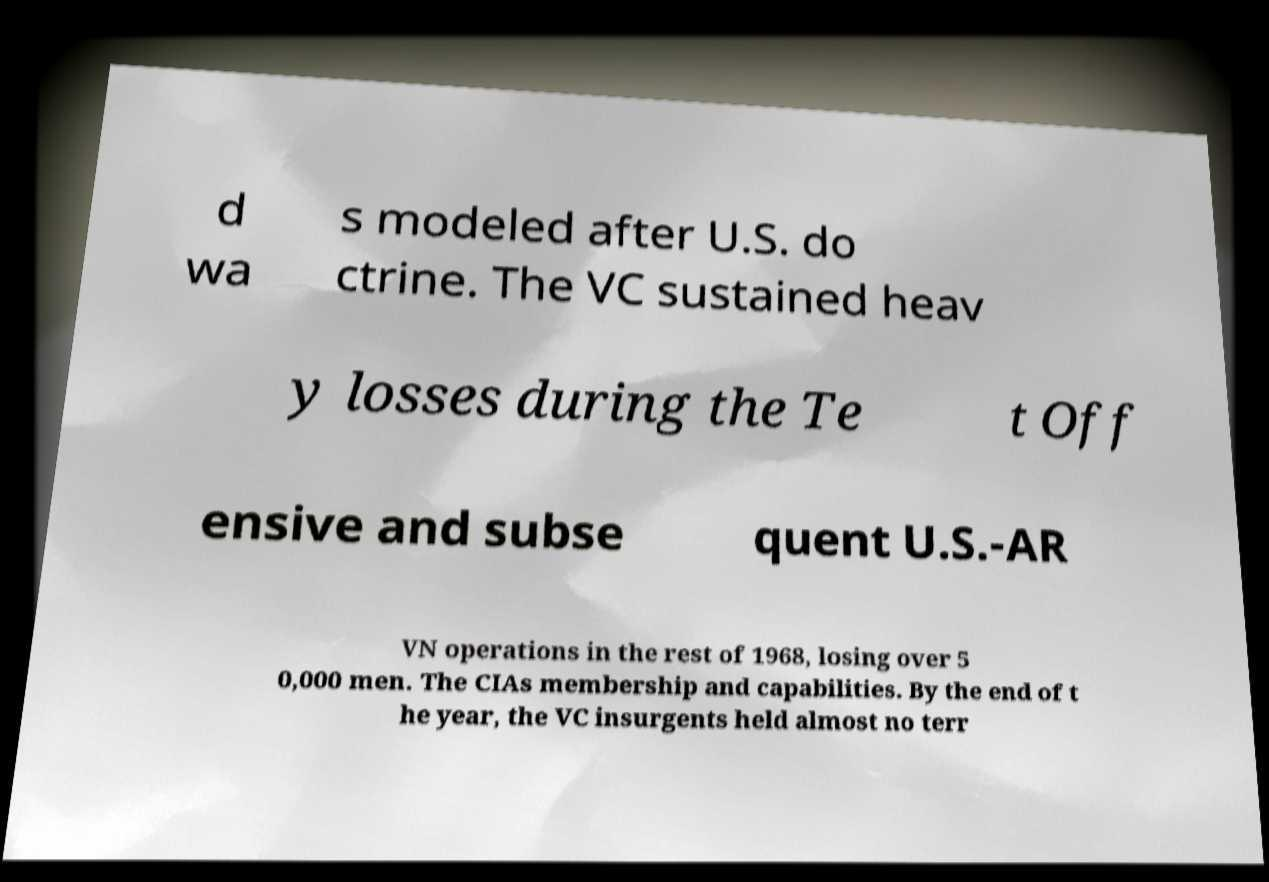I need the written content from this picture converted into text. Can you do that? d wa s modeled after U.S. do ctrine. The VC sustained heav y losses during the Te t Off ensive and subse quent U.S.-AR VN operations in the rest of 1968, losing over 5 0,000 men. The CIAs membership and capabilities. By the end of t he year, the VC insurgents held almost no terr 